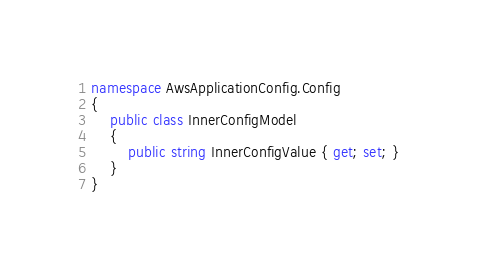Convert code to text. <code><loc_0><loc_0><loc_500><loc_500><_C#_>namespace AwsApplicationConfig.Config
{
    public class InnerConfigModel
    {
        public string InnerConfigValue { get; set; }
    }
}
</code> 